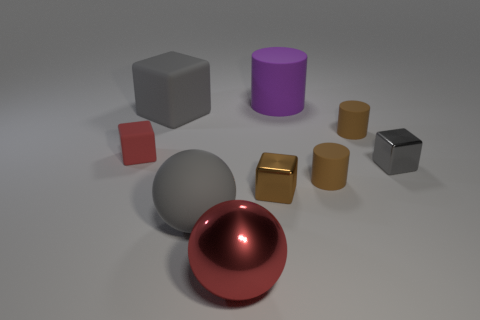What size is the matte thing that is the same color as the large matte ball?
Your answer should be compact. Large. Are there any big gray cubes that have the same material as the large cylinder?
Provide a succinct answer. Yes. What color is the small matte block?
Offer a very short reply. Red. How big is the cube to the right of the large purple matte object that is to the right of the shiny thing that is in front of the brown block?
Your answer should be compact. Small. How many other things are the same shape as the large red metallic object?
Your answer should be very brief. 1. There is a thing that is both on the left side of the big metallic ball and on the right side of the large gray block; what color is it?
Make the answer very short. Gray. Is there anything else that is the same size as the purple matte object?
Your answer should be compact. Yes. Is the color of the large cube on the left side of the red sphere the same as the big cylinder?
Give a very brief answer. No. How many cylinders are gray metallic things or big metal things?
Your response must be concise. 0. What is the shape of the tiny thing that is to the left of the small brown block?
Keep it short and to the point. Cube. 